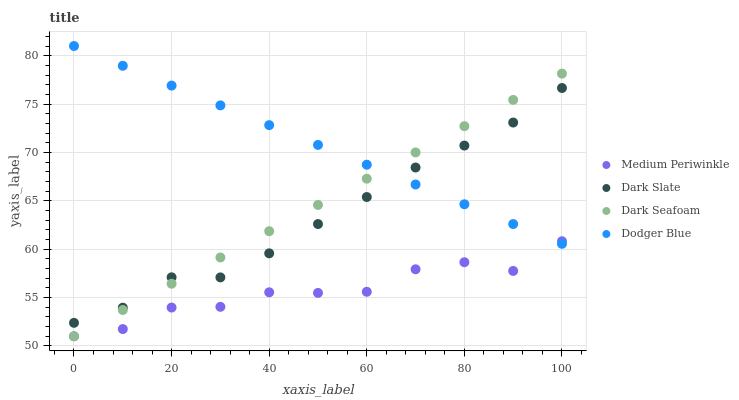Does Medium Periwinkle have the minimum area under the curve?
Answer yes or no. Yes. Does Dodger Blue have the maximum area under the curve?
Answer yes or no. Yes. Does Dark Seafoam have the minimum area under the curve?
Answer yes or no. No. Does Dark Seafoam have the maximum area under the curve?
Answer yes or no. No. Is Dark Seafoam the smoothest?
Answer yes or no. Yes. Is Medium Periwinkle the roughest?
Answer yes or no. Yes. Is Medium Periwinkle the smoothest?
Answer yes or no. No. Is Dark Seafoam the roughest?
Answer yes or no. No. Does Dark Seafoam have the lowest value?
Answer yes or no. Yes. Does Dodger Blue have the lowest value?
Answer yes or no. No. Does Dodger Blue have the highest value?
Answer yes or no. Yes. Does Dark Seafoam have the highest value?
Answer yes or no. No. Is Medium Periwinkle less than Dark Slate?
Answer yes or no. Yes. Is Dark Slate greater than Medium Periwinkle?
Answer yes or no. Yes. Does Medium Periwinkle intersect Dark Seafoam?
Answer yes or no. Yes. Is Medium Periwinkle less than Dark Seafoam?
Answer yes or no. No. Is Medium Periwinkle greater than Dark Seafoam?
Answer yes or no. No. Does Medium Periwinkle intersect Dark Slate?
Answer yes or no. No. 